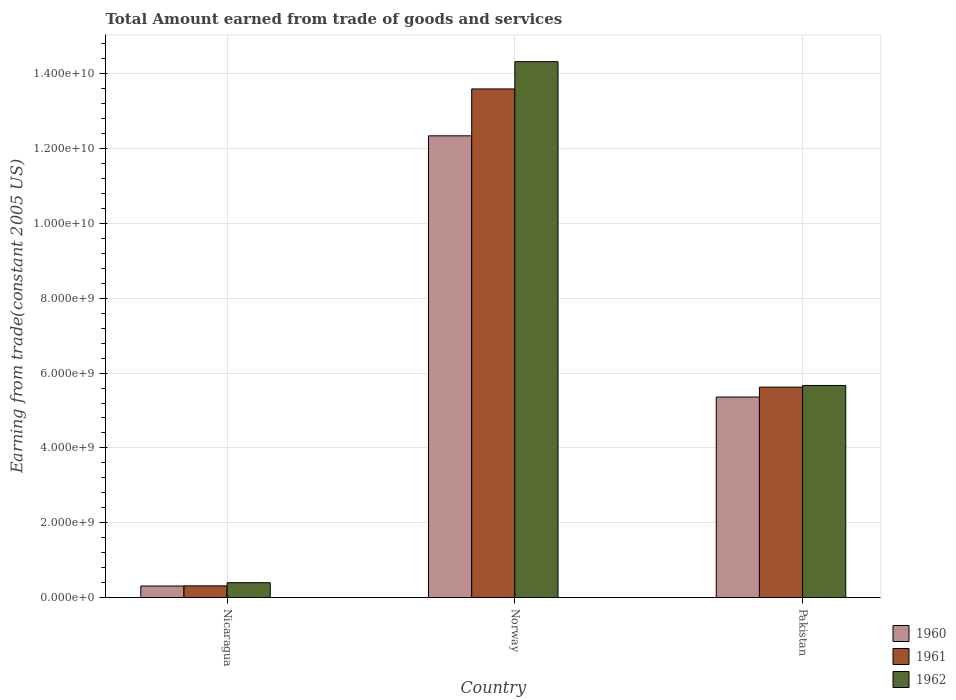How many different coloured bars are there?
Give a very brief answer. 3. How many bars are there on the 2nd tick from the right?
Ensure brevity in your answer.  3. What is the label of the 1st group of bars from the left?
Make the answer very short. Nicaragua. In how many cases, is the number of bars for a given country not equal to the number of legend labels?
Offer a terse response. 0. What is the total amount earned by trading goods and services in 1961 in Pakistan?
Provide a short and direct response. 5.62e+09. Across all countries, what is the maximum total amount earned by trading goods and services in 1961?
Give a very brief answer. 1.36e+1. Across all countries, what is the minimum total amount earned by trading goods and services in 1961?
Your answer should be very brief. 3.12e+08. In which country was the total amount earned by trading goods and services in 1960 minimum?
Provide a succinct answer. Nicaragua. What is the total total amount earned by trading goods and services in 1960 in the graph?
Provide a short and direct response. 1.80e+1. What is the difference between the total amount earned by trading goods and services in 1962 in Nicaragua and that in Norway?
Offer a terse response. -1.39e+1. What is the difference between the total amount earned by trading goods and services in 1961 in Pakistan and the total amount earned by trading goods and services in 1960 in Norway?
Your answer should be compact. -6.72e+09. What is the average total amount earned by trading goods and services in 1961 per country?
Provide a short and direct response. 6.51e+09. What is the difference between the total amount earned by trading goods and services of/in 1960 and total amount earned by trading goods and services of/in 1961 in Norway?
Make the answer very short. -1.25e+09. In how many countries, is the total amount earned by trading goods and services in 1961 greater than 13200000000 US$?
Make the answer very short. 1. What is the ratio of the total amount earned by trading goods and services in 1960 in Nicaragua to that in Pakistan?
Offer a very short reply. 0.06. What is the difference between the highest and the second highest total amount earned by trading goods and services in 1960?
Provide a short and direct response. -6.98e+09. What is the difference between the highest and the lowest total amount earned by trading goods and services in 1961?
Keep it short and to the point. 1.33e+1. Is the sum of the total amount earned by trading goods and services in 1962 in Norway and Pakistan greater than the maximum total amount earned by trading goods and services in 1961 across all countries?
Your answer should be compact. Yes. What does the 1st bar from the left in Pakistan represents?
Make the answer very short. 1960. Is it the case that in every country, the sum of the total amount earned by trading goods and services in 1960 and total amount earned by trading goods and services in 1962 is greater than the total amount earned by trading goods and services in 1961?
Provide a short and direct response. Yes. What is the difference between two consecutive major ticks on the Y-axis?
Provide a short and direct response. 2.00e+09. Does the graph contain any zero values?
Ensure brevity in your answer.  No. Does the graph contain grids?
Give a very brief answer. Yes. Where does the legend appear in the graph?
Your answer should be compact. Bottom right. How many legend labels are there?
Your answer should be very brief. 3. How are the legend labels stacked?
Provide a succinct answer. Vertical. What is the title of the graph?
Ensure brevity in your answer.  Total Amount earned from trade of goods and services. What is the label or title of the Y-axis?
Your answer should be compact. Earning from trade(constant 2005 US). What is the Earning from trade(constant 2005 US) in 1960 in Nicaragua?
Provide a short and direct response. 3.07e+08. What is the Earning from trade(constant 2005 US) in 1961 in Nicaragua?
Make the answer very short. 3.12e+08. What is the Earning from trade(constant 2005 US) of 1962 in Nicaragua?
Provide a short and direct response. 3.97e+08. What is the Earning from trade(constant 2005 US) in 1960 in Norway?
Make the answer very short. 1.23e+1. What is the Earning from trade(constant 2005 US) of 1961 in Norway?
Keep it short and to the point. 1.36e+1. What is the Earning from trade(constant 2005 US) in 1962 in Norway?
Keep it short and to the point. 1.43e+1. What is the Earning from trade(constant 2005 US) of 1960 in Pakistan?
Your answer should be compact. 5.36e+09. What is the Earning from trade(constant 2005 US) of 1961 in Pakistan?
Provide a short and direct response. 5.62e+09. What is the Earning from trade(constant 2005 US) in 1962 in Pakistan?
Ensure brevity in your answer.  5.67e+09. Across all countries, what is the maximum Earning from trade(constant 2005 US) in 1960?
Give a very brief answer. 1.23e+1. Across all countries, what is the maximum Earning from trade(constant 2005 US) in 1961?
Offer a very short reply. 1.36e+1. Across all countries, what is the maximum Earning from trade(constant 2005 US) in 1962?
Ensure brevity in your answer.  1.43e+1. Across all countries, what is the minimum Earning from trade(constant 2005 US) in 1960?
Offer a very short reply. 3.07e+08. Across all countries, what is the minimum Earning from trade(constant 2005 US) of 1961?
Make the answer very short. 3.12e+08. Across all countries, what is the minimum Earning from trade(constant 2005 US) in 1962?
Offer a very short reply. 3.97e+08. What is the total Earning from trade(constant 2005 US) of 1960 in the graph?
Your answer should be very brief. 1.80e+1. What is the total Earning from trade(constant 2005 US) of 1961 in the graph?
Offer a very short reply. 1.95e+1. What is the total Earning from trade(constant 2005 US) in 1962 in the graph?
Offer a very short reply. 2.04e+1. What is the difference between the Earning from trade(constant 2005 US) of 1960 in Nicaragua and that in Norway?
Your response must be concise. -1.20e+1. What is the difference between the Earning from trade(constant 2005 US) of 1961 in Nicaragua and that in Norway?
Your response must be concise. -1.33e+1. What is the difference between the Earning from trade(constant 2005 US) in 1962 in Nicaragua and that in Norway?
Provide a short and direct response. -1.39e+1. What is the difference between the Earning from trade(constant 2005 US) of 1960 in Nicaragua and that in Pakistan?
Offer a very short reply. -5.05e+09. What is the difference between the Earning from trade(constant 2005 US) of 1961 in Nicaragua and that in Pakistan?
Provide a succinct answer. -5.31e+09. What is the difference between the Earning from trade(constant 2005 US) in 1962 in Nicaragua and that in Pakistan?
Your answer should be very brief. -5.27e+09. What is the difference between the Earning from trade(constant 2005 US) of 1960 in Norway and that in Pakistan?
Provide a short and direct response. 6.98e+09. What is the difference between the Earning from trade(constant 2005 US) in 1961 in Norway and that in Pakistan?
Provide a short and direct response. 7.97e+09. What is the difference between the Earning from trade(constant 2005 US) in 1962 in Norway and that in Pakistan?
Keep it short and to the point. 8.66e+09. What is the difference between the Earning from trade(constant 2005 US) of 1960 in Nicaragua and the Earning from trade(constant 2005 US) of 1961 in Norway?
Ensure brevity in your answer.  -1.33e+1. What is the difference between the Earning from trade(constant 2005 US) in 1960 in Nicaragua and the Earning from trade(constant 2005 US) in 1962 in Norway?
Give a very brief answer. -1.40e+1. What is the difference between the Earning from trade(constant 2005 US) of 1961 in Nicaragua and the Earning from trade(constant 2005 US) of 1962 in Norway?
Offer a very short reply. -1.40e+1. What is the difference between the Earning from trade(constant 2005 US) of 1960 in Nicaragua and the Earning from trade(constant 2005 US) of 1961 in Pakistan?
Keep it short and to the point. -5.32e+09. What is the difference between the Earning from trade(constant 2005 US) in 1960 in Nicaragua and the Earning from trade(constant 2005 US) in 1962 in Pakistan?
Your answer should be compact. -5.36e+09. What is the difference between the Earning from trade(constant 2005 US) in 1961 in Nicaragua and the Earning from trade(constant 2005 US) in 1962 in Pakistan?
Your answer should be compact. -5.36e+09. What is the difference between the Earning from trade(constant 2005 US) of 1960 in Norway and the Earning from trade(constant 2005 US) of 1961 in Pakistan?
Your answer should be very brief. 6.72e+09. What is the difference between the Earning from trade(constant 2005 US) of 1960 in Norway and the Earning from trade(constant 2005 US) of 1962 in Pakistan?
Your answer should be compact. 6.67e+09. What is the difference between the Earning from trade(constant 2005 US) of 1961 in Norway and the Earning from trade(constant 2005 US) of 1962 in Pakistan?
Make the answer very short. 7.93e+09. What is the average Earning from trade(constant 2005 US) of 1960 per country?
Make the answer very short. 6.00e+09. What is the average Earning from trade(constant 2005 US) of 1961 per country?
Make the answer very short. 6.51e+09. What is the average Earning from trade(constant 2005 US) in 1962 per country?
Offer a very short reply. 6.80e+09. What is the difference between the Earning from trade(constant 2005 US) of 1960 and Earning from trade(constant 2005 US) of 1961 in Nicaragua?
Make the answer very short. -4.39e+06. What is the difference between the Earning from trade(constant 2005 US) in 1960 and Earning from trade(constant 2005 US) in 1962 in Nicaragua?
Keep it short and to the point. -8.93e+07. What is the difference between the Earning from trade(constant 2005 US) of 1961 and Earning from trade(constant 2005 US) of 1962 in Nicaragua?
Provide a short and direct response. -8.49e+07. What is the difference between the Earning from trade(constant 2005 US) in 1960 and Earning from trade(constant 2005 US) in 1961 in Norway?
Offer a terse response. -1.25e+09. What is the difference between the Earning from trade(constant 2005 US) in 1960 and Earning from trade(constant 2005 US) in 1962 in Norway?
Make the answer very short. -1.98e+09. What is the difference between the Earning from trade(constant 2005 US) of 1961 and Earning from trade(constant 2005 US) of 1962 in Norway?
Your answer should be very brief. -7.29e+08. What is the difference between the Earning from trade(constant 2005 US) in 1960 and Earning from trade(constant 2005 US) in 1961 in Pakistan?
Offer a terse response. -2.64e+08. What is the difference between the Earning from trade(constant 2005 US) in 1960 and Earning from trade(constant 2005 US) in 1962 in Pakistan?
Provide a short and direct response. -3.09e+08. What is the difference between the Earning from trade(constant 2005 US) in 1961 and Earning from trade(constant 2005 US) in 1962 in Pakistan?
Make the answer very short. -4.48e+07. What is the ratio of the Earning from trade(constant 2005 US) in 1960 in Nicaragua to that in Norway?
Your answer should be very brief. 0.02. What is the ratio of the Earning from trade(constant 2005 US) in 1961 in Nicaragua to that in Norway?
Make the answer very short. 0.02. What is the ratio of the Earning from trade(constant 2005 US) of 1962 in Nicaragua to that in Norway?
Make the answer very short. 0.03. What is the ratio of the Earning from trade(constant 2005 US) of 1960 in Nicaragua to that in Pakistan?
Ensure brevity in your answer.  0.06. What is the ratio of the Earning from trade(constant 2005 US) in 1961 in Nicaragua to that in Pakistan?
Your answer should be compact. 0.06. What is the ratio of the Earning from trade(constant 2005 US) of 1962 in Nicaragua to that in Pakistan?
Your answer should be compact. 0.07. What is the ratio of the Earning from trade(constant 2005 US) in 1960 in Norway to that in Pakistan?
Offer a terse response. 2.3. What is the ratio of the Earning from trade(constant 2005 US) in 1961 in Norway to that in Pakistan?
Your answer should be very brief. 2.42. What is the ratio of the Earning from trade(constant 2005 US) of 1962 in Norway to that in Pakistan?
Offer a very short reply. 2.53. What is the difference between the highest and the second highest Earning from trade(constant 2005 US) of 1960?
Make the answer very short. 6.98e+09. What is the difference between the highest and the second highest Earning from trade(constant 2005 US) of 1961?
Keep it short and to the point. 7.97e+09. What is the difference between the highest and the second highest Earning from trade(constant 2005 US) in 1962?
Provide a succinct answer. 8.66e+09. What is the difference between the highest and the lowest Earning from trade(constant 2005 US) of 1960?
Ensure brevity in your answer.  1.20e+1. What is the difference between the highest and the lowest Earning from trade(constant 2005 US) in 1961?
Keep it short and to the point. 1.33e+1. What is the difference between the highest and the lowest Earning from trade(constant 2005 US) of 1962?
Offer a terse response. 1.39e+1. 